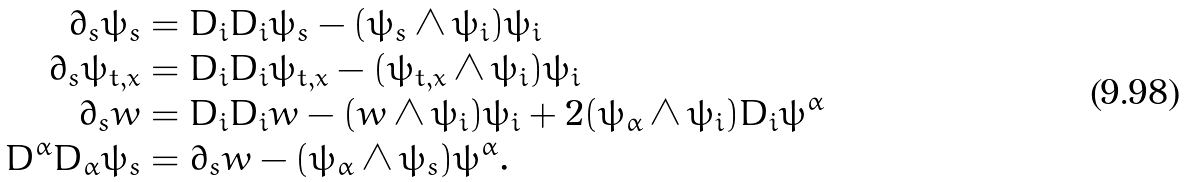Convert formula to latex. <formula><loc_0><loc_0><loc_500><loc_500>\partial _ { s } \psi _ { s } & = D _ { i } D _ { i } \psi _ { s } - ( \psi _ { s } \wedge \psi _ { i } ) \psi _ { i } \\ \partial _ { s } \psi _ { t , x } & = D _ { i } D _ { i } \psi _ { t , x } - ( \psi _ { t , x } \wedge \psi _ { i } ) \psi _ { i } \\ \partial _ { s } w & = D _ { i } D _ { i } w - ( w \wedge \psi _ { i } ) \psi _ { i } + 2 ( \psi _ { \alpha } \wedge \psi _ { i } ) D _ { i } \psi ^ { \alpha } \\ D ^ { \alpha } D _ { \alpha } \psi _ { s } & = \partial _ { s } w - ( \psi _ { \alpha } \wedge \psi _ { s } ) \psi ^ { \alpha } .</formula> 